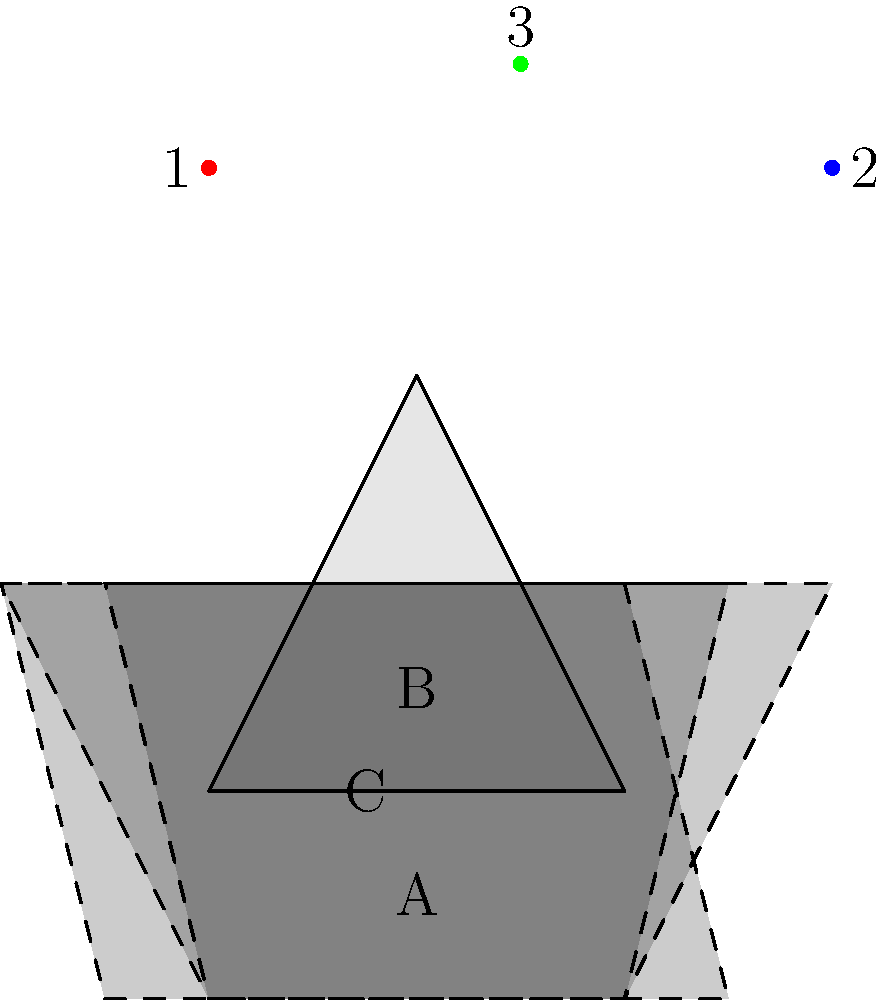As a child advocate, you're organizing a shadow puppet workshop. A triangular toy is illuminated by three different light sources (1, 2, and 3) as shown in the diagram. Which shadow (A, B, or C) corresponds to light source 2? To determine which shadow corresponds to light source 2, we need to analyze the position of each light source and how it would cast a shadow of the triangular toy:

1. Light source 1 (red dot) is positioned to the left of the toy. This would cast a shadow that extends to the right and slightly upwards, which doesn't match any of the given shadows.

2. Light source 2 (blue dot) is positioned to the right of the toy. This would cast a shadow that extends to the left and slightly upwards.

3. Light source 3 (green dot) is positioned directly above the toy. This would cast a shadow that extends equally to both sides and downwards.

Looking at the shadows:

A: This shadow extends more to the left, indicating it's cast by a light source on the right.
B: This shadow extends equally to both sides, suggesting it's cast by a light source directly above.
C: This shadow extends more to the right, indicating it's cast by a light source on the left.

Therefore, shadow A corresponds to light source 2, as it's the only shadow that extends more to the left, which would be caused by a light source on the right.
Answer: A 